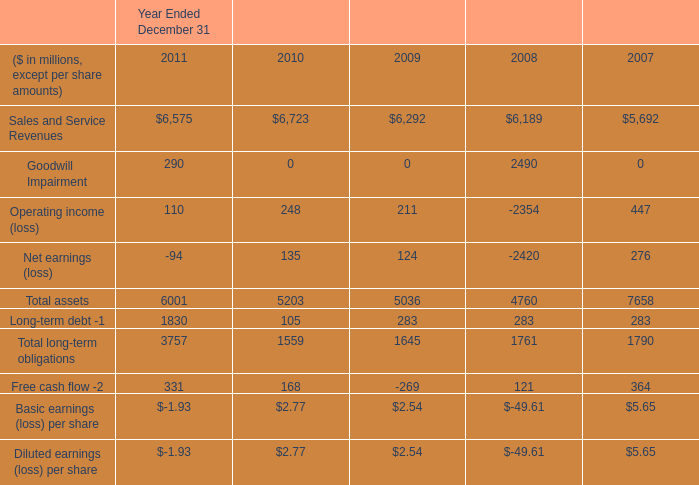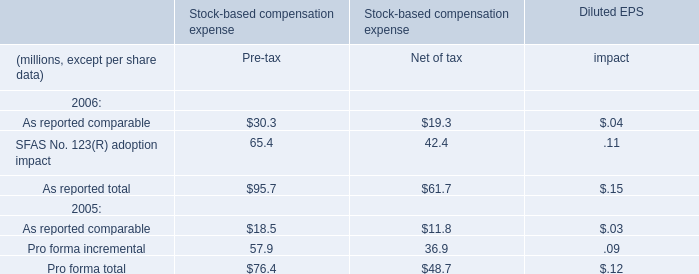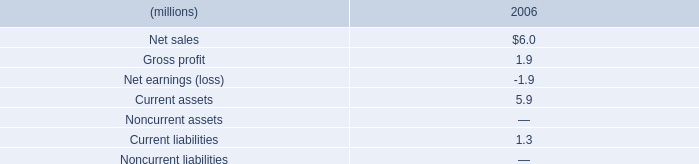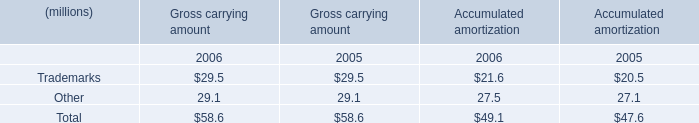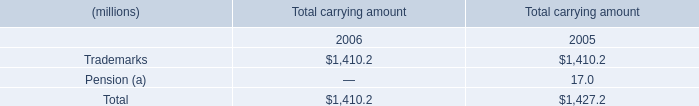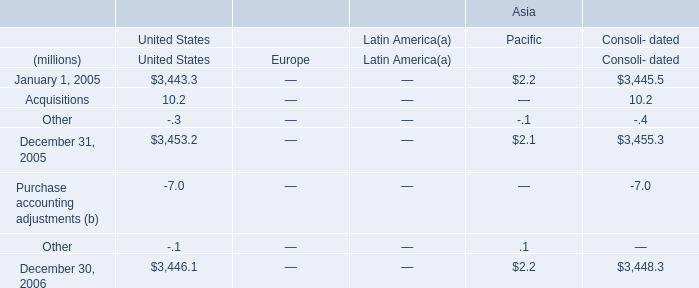In the year with the most Total carrying amount totally, what is the value of Pension for Total carrying amount? (in million) 
Answer: 17.0. 